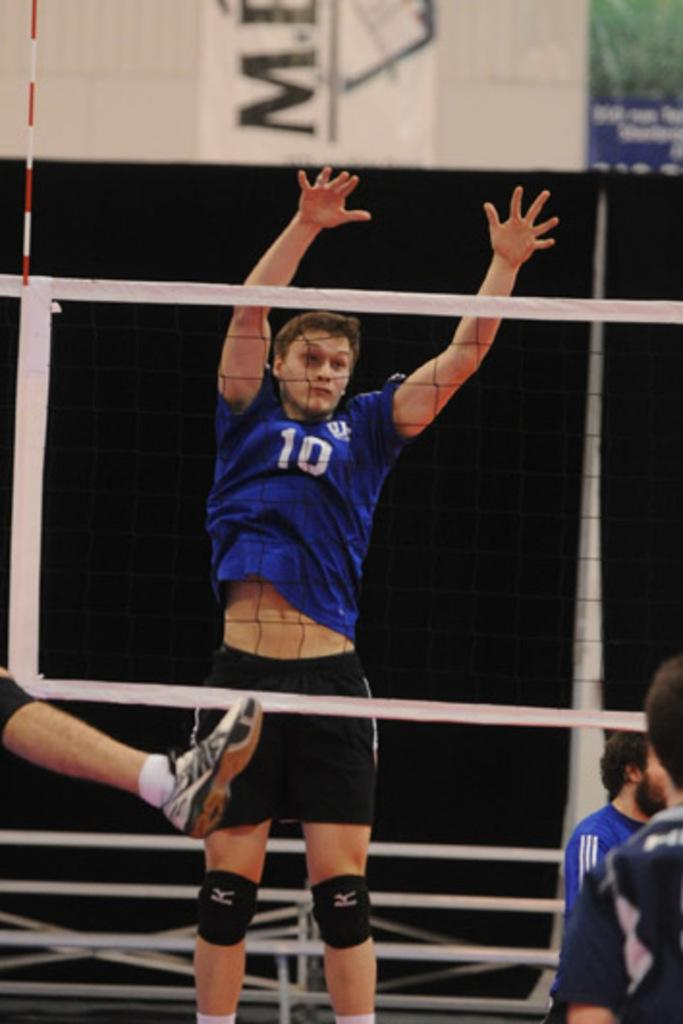<image>
Share a concise interpretation of the image provided. A man is jumping in the air with the number 10 on his shirt. 